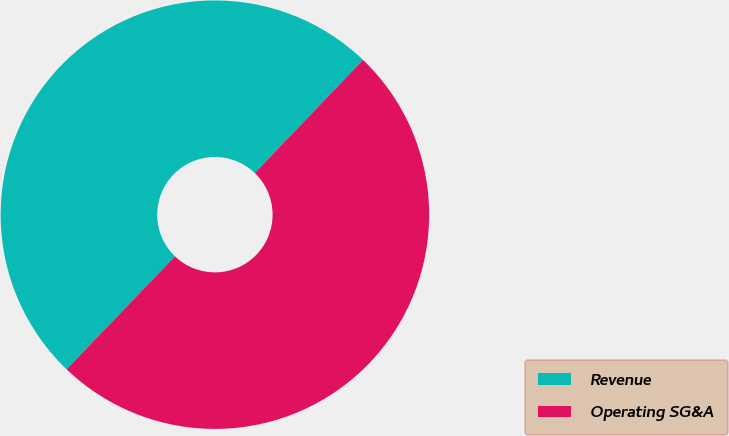<chart> <loc_0><loc_0><loc_500><loc_500><pie_chart><fcel>Revenue<fcel>Operating SG&A<nl><fcel>49.98%<fcel>50.02%<nl></chart> 